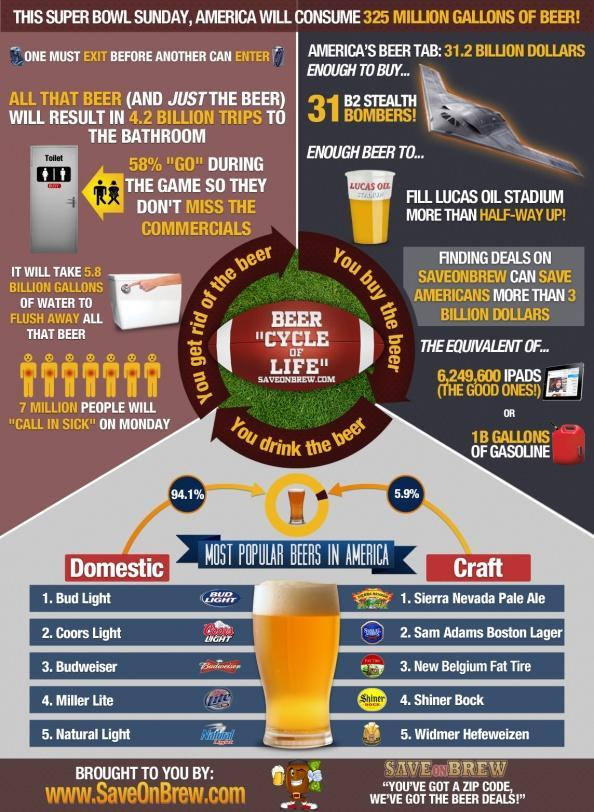What percentage of domestic beers are used in America?
Answer the question with a short phrase. 94.1% What percentage of craft beers are used in America? 5.9% 